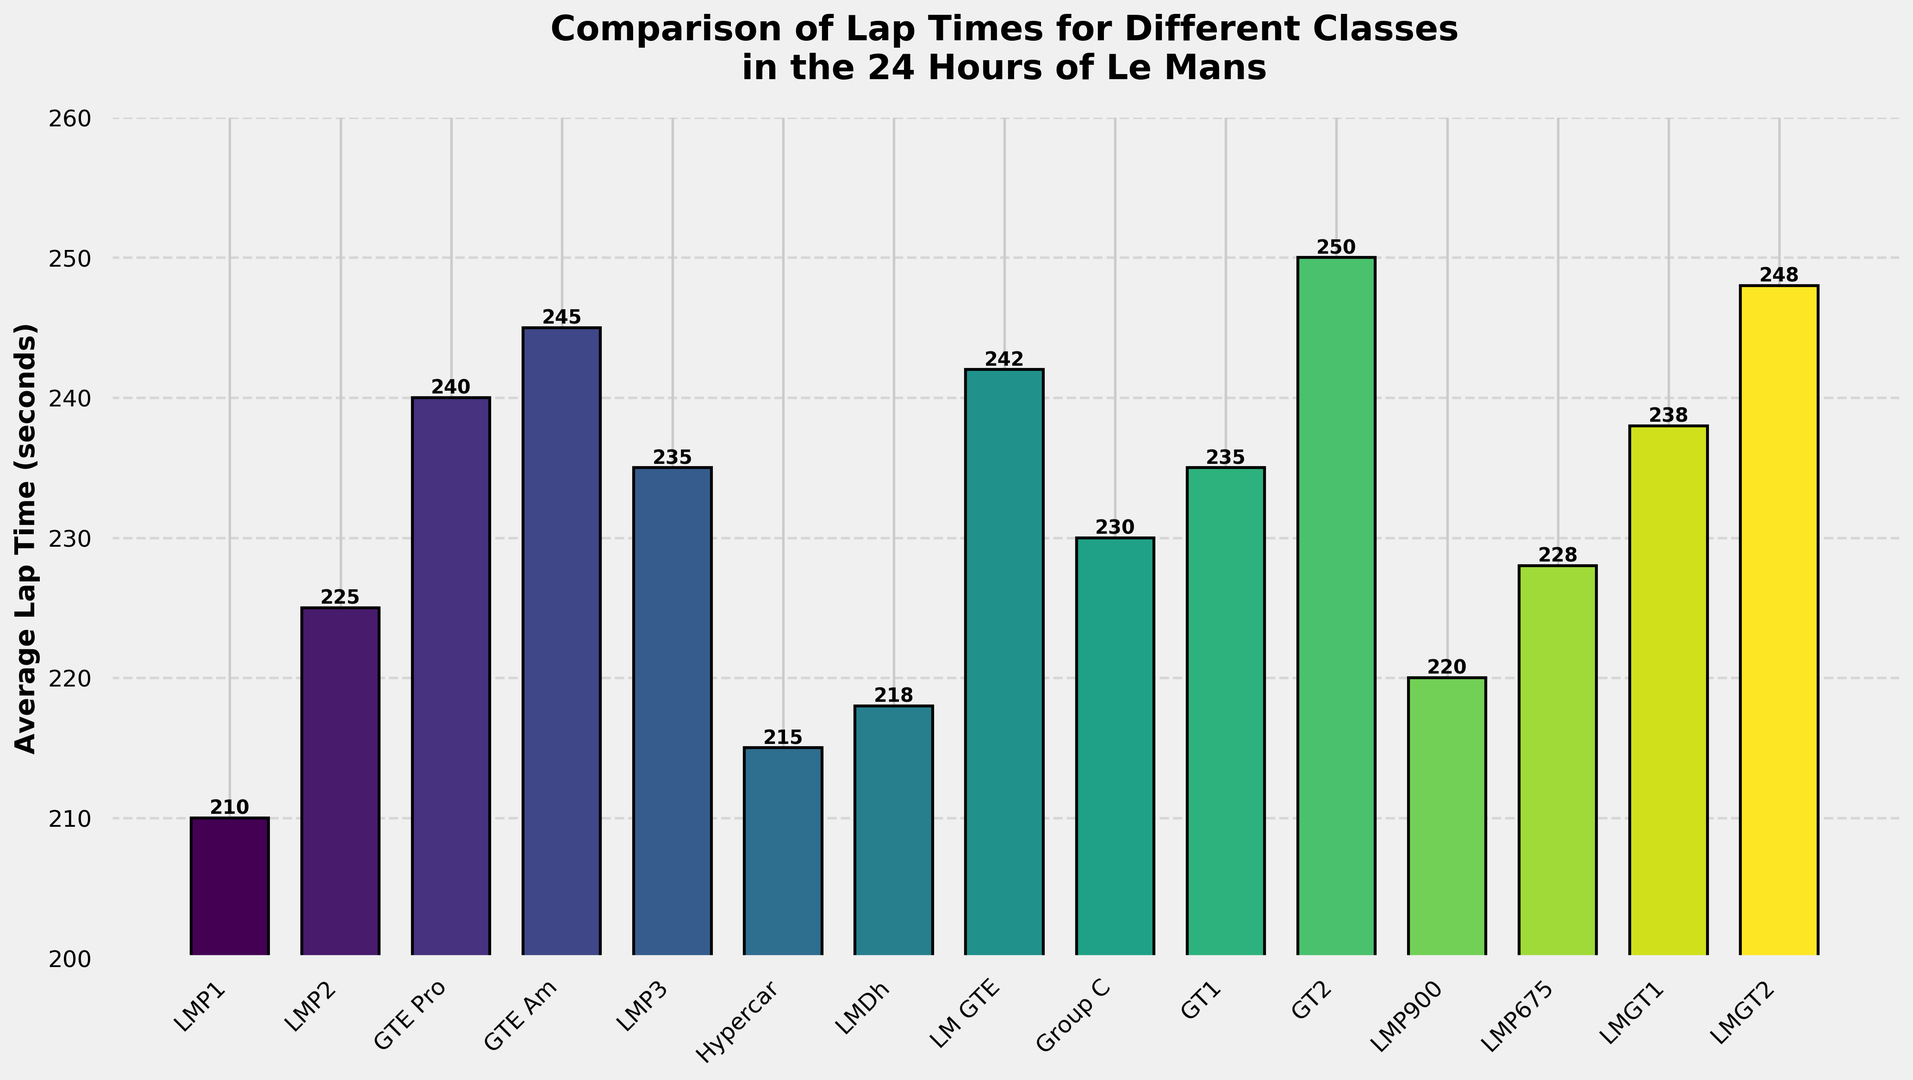What is the class with the fastest average lap time? By looking at the bar chart, the shortest bar represents the fastest average lap time. The chart shows that the 'LMP1' class has the shortest bar, indicating the fastest lap time.
Answer: LMP1 Which class has a longer average lap time, LMP675 or LM GTE? Comparing the heights of the bars representing 'LMP675' and 'LM GTE', the 'LM GTE' bar is slightly taller, indicating a longer average lap time.
Answer: LM GTE How much longer is the average lap time of GTE Am compared to LMP1? The average lap time for 'GTE Am' is 245 seconds, and for 'LMP1' it is 210 seconds. The difference is 245 - 210 = 35 seconds.
Answer: 35 seconds What is the average lap time difference between the Hypercar and LMP3 classes? The average lap times for 'Hypercar' and 'LMP3' are 215 seconds and 235 seconds respectively. The difference is 235 - 215 = 20 seconds.
Answer: 20 seconds Which class has the average lap time closest to Hypercar? The average lap time for 'Hypercar' is 215 seconds. By comparing the bars, 'LMDh' has an average lap time of 218 seconds which is closest to 215 seconds.
Answer: LMDh Which two classes have exactly the same average lap times? By examining the bars, 'GT1' and 'LMP3' both have the same average lap time of 235 seconds.
Answer: GT1 and LMP3 What is the average lap time of GTE Pro and LMGT2? The average lap times of 'GTE Pro' and 'LMGT2' are 240 and 248 seconds respectively. The average is (240 + 248) / 2 = 244 seconds.
Answer: 244 seconds Which class has an average lap time of 250 seconds? The chart shows that the class with an average lap time of 250 seconds is 'GT2'.
Answer: GT2 What is the range of average lap times across all classes? The fastest lap time is 210 seconds by 'LMP1' and the slowest is 250 seconds by 'GT2'. The range is 250 - 210 = 40 seconds.
Answer: 40 seconds Which class has the second fastest lap time, and what is it? 'LMP1' is the fastest at 210 seconds. The next shortest bar corresponds to 'Hypercar' with an average lap time of 215 seconds.
Answer: Hypercar, 215 seconds 